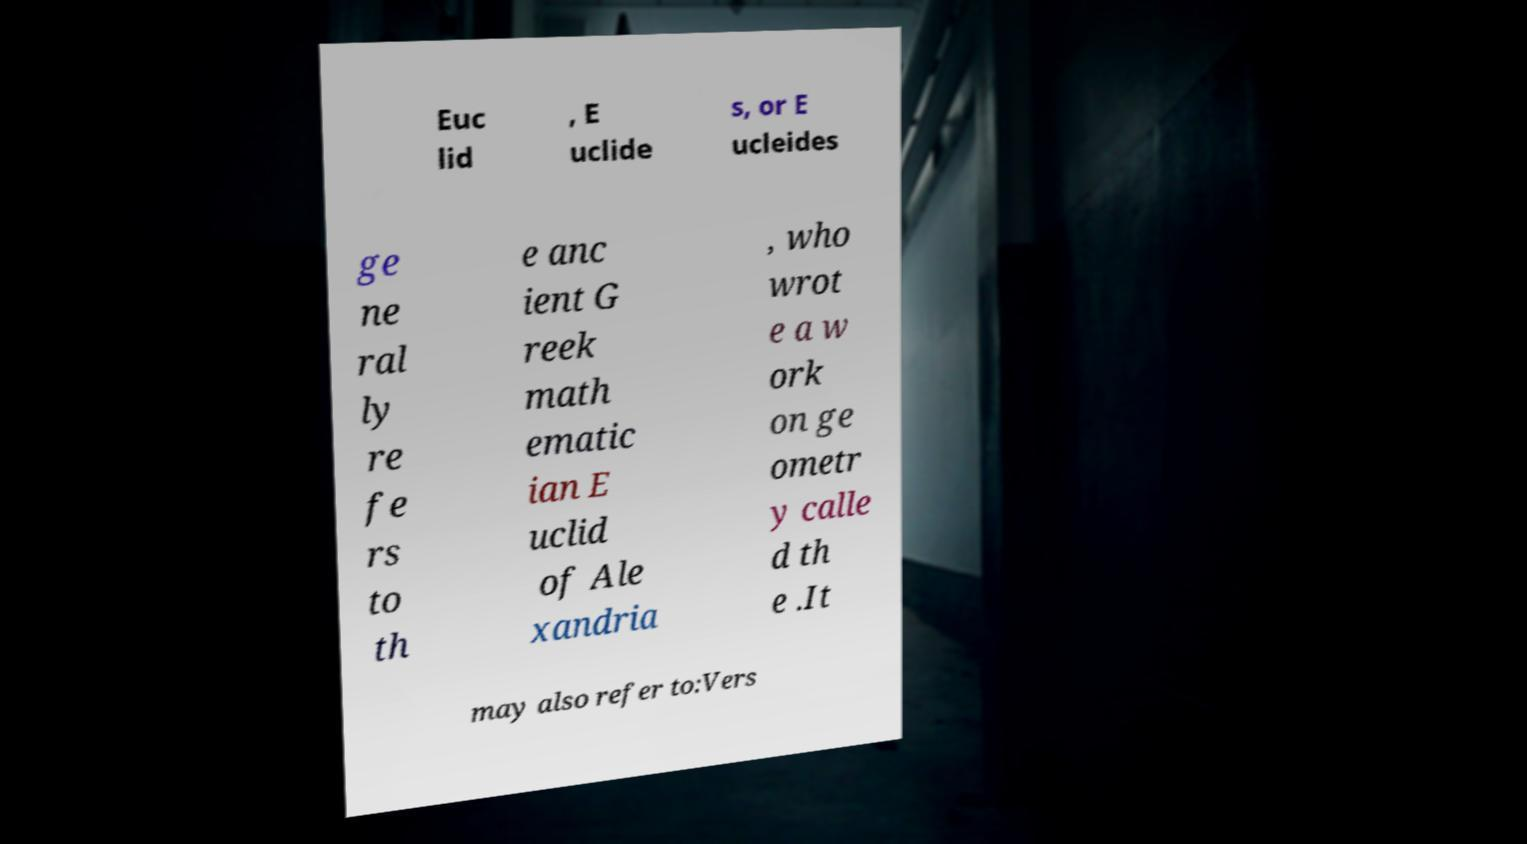What messages or text are displayed in this image? I need them in a readable, typed format. Euc lid , E uclide s, or E ucleides ge ne ral ly re fe rs to th e anc ient G reek math ematic ian E uclid of Ale xandria , who wrot e a w ork on ge ometr y calle d th e .It may also refer to:Vers 